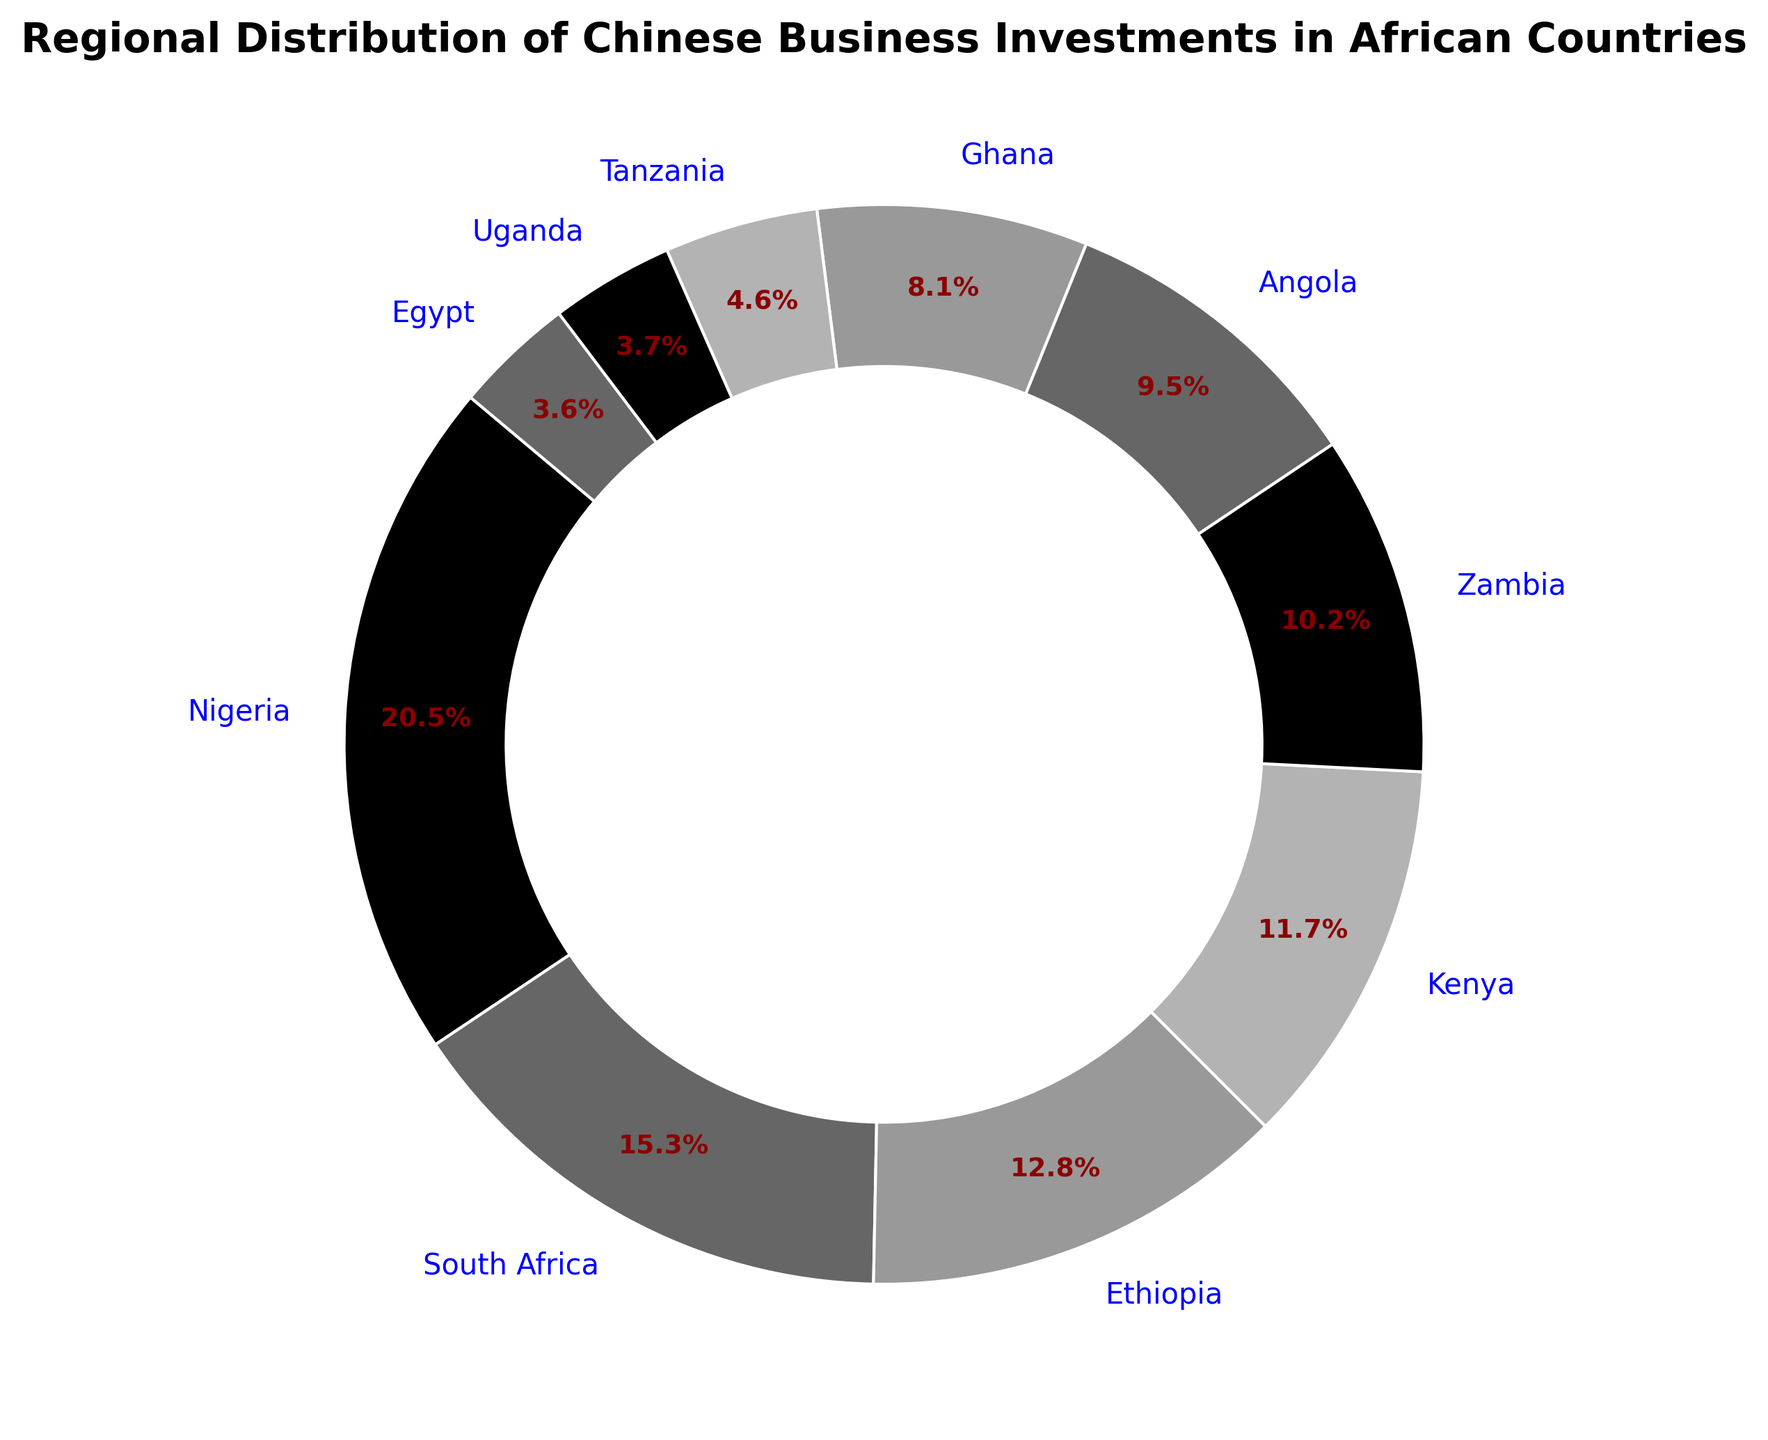What's the country with the highest percentage of Chinese investment? The figure shows the percentages of Chinese investments in different African countries. By looking at the visual distribution, we can see that Nigeria has the largest slice.
Answer: Nigeria How does the investment in South Africa compare to Kenya? By visually comparing the slices of the pie chart, South Africa has a larger slice than Kenya. South Africa's investment percentage is 15.3%, while Kenya's is 11.7%.
Answer: South Africa has a higher percentage than Kenya What's the total percentage of Chinese investment in Ethiopia, Zambia, and Tanzania combined? Summing the investment percentages for Ethiopia (12.8%), Zambia (10.2%), and Tanzania (4.6%) together: 12.8 + 10.2 + 4.6 = 27.6%.
Answer: 27.6% Which country has the smallest percentage of Chinese investment? The figure shows the percentages of investments, and the smallest slice corresponds to Egypt, with 3.6%.
Answer: Egypt How much more investment does Nigeria have compared to Ghana? Nigeria has 20.5% and Ghana has 8.1%. The difference is 20.5 - 8.1 = 12.4%.
Answer: 12.4% What's the combined investment percentage in Nigeria and South Africa? Adding Nigeria's (20.5%) and South Africa's (15.3%) percentages: 20.5 + 15.3 = 35.8%.
Answer: 35.8% If the total investment is doubled, what would be the new percentage for Kenya? Percentages always sum up to 100%, so if we double the total investment, the individual percentages would remain the same. Kenya's percentage will still be 11.7%.
Answer: 11.7% How many countries have a Chinese investment percentage of over 10%? From the figure, Nigeria (20.5%), South Africa (15.3%), Ethiopia (12.8%), Kenya (11.7%), and Zambia (10.2%) each have over 10%. Counting these, there are 5 countries.
Answer: 5 What is the visual difference between the slices representing Kenya and Tanzania? The slice size for Kenya is visibly larger and takes up a bigger portion of the pie chart compared to Tanzania's slice. Kenya has 11.7% while Tanzania has 4.6%.
Answer: Kenya's slice is larger than Tanzania's slice What's the average investment percentage for Ghana, Uganda, and Egypt? Adding Ghana (8.1%), Uganda (3.7%), and Egypt's (3.6%) percentages and then dividing by 3: (8.1 + 3.7 + 3.6) / 3 = 5.13%.
Answer: 5.13% 